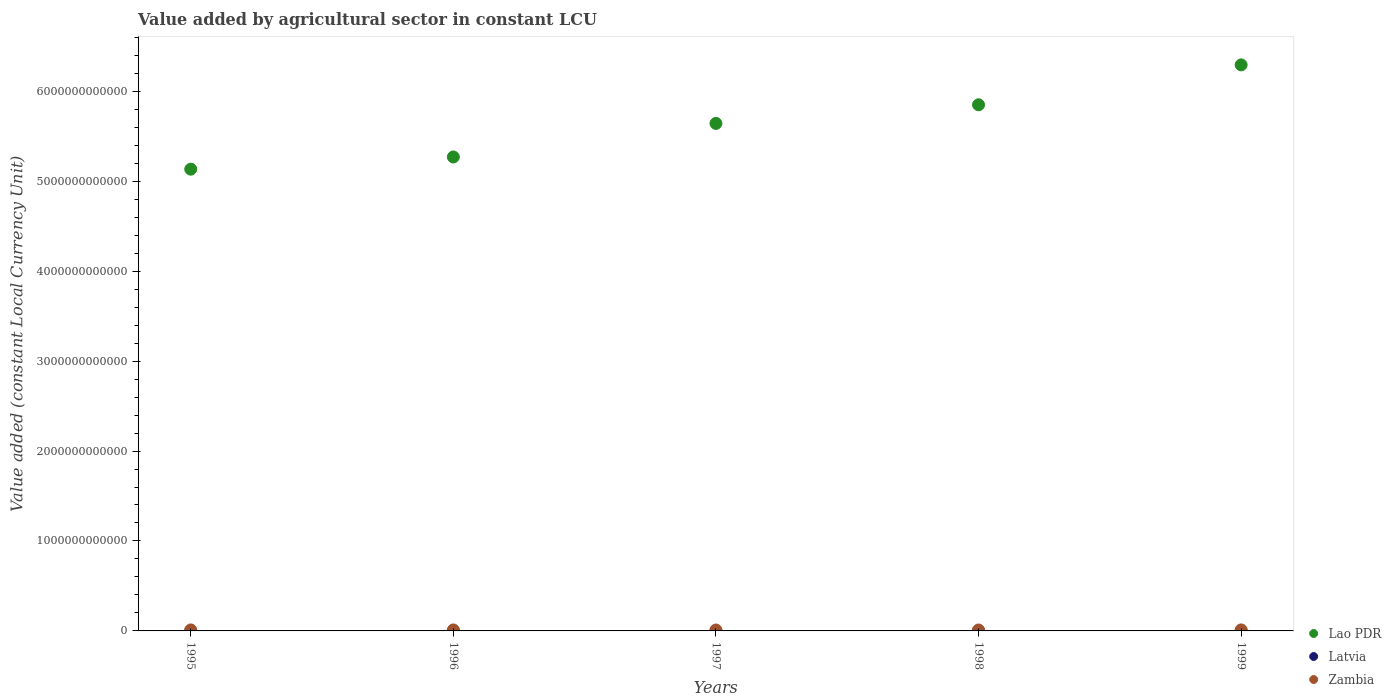How many different coloured dotlines are there?
Offer a very short reply. 3. Is the number of dotlines equal to the number of legend labels?
Provide a short and direct response. Yes. What is the value added by agricultural sector in Lao PDR in 1997?
Your answer should be very brief. 5.64e+12. Across all years, what is the maximum value added by agricultural sector in Zambia?
Offer a very short reply. 1.12e+1. Across all years, what is the minimum value added by agricultural sector in Lao PDR?
Your answer should be very brief. 5.13e+12. What is the total value added by agricultural sector in Zambia in the graph?
Your answer should be compact. 5.40e+1. What is the difference between the value added by agricultural sector in Latvia in 1995 and that in 1999?
Make the answer very short. 5.43e+07. What is the difference between the value added by agricultural sector in Zambia in 1998 and the value added by agricultural sector in Lao PDR in 1996?
Give a very brief answer. -5.26e+12. What is the average value added by agricultural sector in Latvia per year?
Your response must be concise. 4.92e+08. In the year 1999, what is the difference between the value added by agricultural sector in Latvia and value added by agricultural sector in Lao PDR?
Your answer should be very brief. -6.29e+12. In how many years, is the value added by agricultural sector in Latvia greater than 1800000000000 LCU?
Give a very brief answer. 0. What is the ratio of the value added by agricultural sector in Lao PDR in 1998 to that in 1999?
Your answer should be compact. 0.93. Is the value added by agricultural sector in Lao PDR in 1996 less than that in 1998?
Ensure brevity in your answer.  Yes. What is the difference between the highest and the second highest value added by agricultural sector in Latvia?
Your answer should be compact. 6.35e+06. What is the difference between the highest and the lowest value added by agricultural sector in Lao PDR?
Your answer should be compact. 1.16e+12. Is the sum of the value added by agricultural sector in Lao PDR in 1996 and 1997 greater than the maximum value added by agricultural sector in Zambia across all years?
Your answer should be compact. Yes. Is it the case that in every year, the sum of the value added by agricultural sector in Zambia and value added by agricultural sector in Latvia  is greater than the value added by agricultural sector in Lao PDR?
Provide a succinct answer. No. Does the value added by agricultural sector in Latvia monotonically increase over the years?
Provide a short and direct response. No. Is the value added by agricultural sector in Lao PDR strictly less than the value added by agricultural sector in Zambia over the years?
Provide a succinct answer. No. What is the difference between two consecutive major ticks on the Y-axis?
Give a very brief answer. 1.00e+12. Does the graph contain grids?
Provide a short and direct response. No. Where does the legend appear in the graph?
Make the answer very short. Bottom right. What is the title of the graph?
Make the answer very short. Value added by agricultural sector in constant LCU. What is the label or title of the X-axis?
Offer a terse response. Years. What is the label or title of the Y-axis?
Make the answer very short. Value added (constant Local Currency Unit). What is the Value added (constant Local Currency Unit) in Lao PDR in 1995?
Make the answer very short. 5.13e+12. What is the Value added (constant Local Currency Unit) of Latvia in 1995?
Offer a very short reply. 5.19e+08. What is the Value added (constant Local Currency Unit) in Zambia in 1995?
Ensure brevity in your answer.  1.11e+1. What is the Value added (constant Local Currency Unit) of Lao PDR in 1996?
Make the answer very short. 5.27e+12. What is the Value added (constant Local Currency Unit) of Latvia in 1996?
Offer a very short reply. 4.73e+08. What is the Value added (constant Local Currency Unit) of Zambia in 1996?
Keep it short and to the point. 1.10e+1. What is the Value added (constant Local Currency Unit) in Lao PDR in 1997?
Keep it short and to the point. 5.64e+12. What is the Value added (constant Local Currency Unit) of Latvia in 1997?
Provide a short and direct response. 5.13e+08. What is the Value added (constant Local Currency Unit) of Zambia in 1997?
Provide a succinct answer. 1.03e+1. What is the Value added (constant Local Currency Unit) of Lao PDR in 1998?
Your answer should be compact. 5.85e+12. What is the Value added (constant Local Currency Unit) in Latvia in 1998?
Provide a succinct answer. 4.89e+08. What is the Value added (constant Local Currency Unit) in Zambia in 1998?
Keep it short and to the point. 1.03e+1. What is the Value added (constant Local Currency Unit) of Lao PDR in 1999?
Offer a terse response. 6.29e+12. What is the Value added (constant Local Currency Unit) of Latvia in 1999?
Your answer should be very brief. 4.65e+08. What is the Value added (constant Local Currency Unit) of Zambia in 1999?
Give a very brief answer. 1.12e+1. Across all years, what is the maximum Value added (constant Local Currency Unit) of Lao PDR?
Offer a very short reply. 6.29e+12. Across all years, what is the maximum Value added (constant Local Currency Unit) in Latvia?
Your answer should be very brief. 5.19e+08. Across all years, what is the maximum Value added (constant Local Currency Unit) of Zambia?
Your answer should be very brief. 1.12e+1. Across all years, what is the minimum Value added (constant Local Currency Unit) in Lao PDR?
Your answer should be very brief. 5.13e+12. Across all years, what is the minimum Value added (constant Local Currency Unit) of Latvia?
Your answer should be compact. 4.65e+08. Across all years, what is the minimum Value added (constant Local Currency Unit) in Zambia?
Give a very brief answer. 1.03e+1. What is the total Value added (constant Local Currency Unit) of Lao PDR in the graph?
Offer a terse response. 2.82e+13. What is the total Value added (constant Local Currency Unit) of Latvia in the graph?
Offer a terse response. 2.46e+09. What is the total Value added (constant Local Currency Unit) of Zambia in the graph?
Offer a terse response. 5.40e+1. What is the difference between the Value added (constant Local Currency Unit) of Lao PDR in 1995 and that in 1996?
Your response must be concise. -1.35e+11. What is the difference between the Value added (constant Local Currency Unit) of Latvia in 1995 and that in 1996?
Offer a very short reply. 4.67e+07. What is the difference between the Value added (constant Local Currency Unit) of Zambia in 1995 and that in 1996?
Provide a succinct answer. 1.53e+08. What is the difference between the Value added (constant Local Currency Unit) in Lao PDR in 1995 and that in 1997?
Provide a short and direct response. -5.09e+11. What is the difference between the Value added (constant Local Currency Unit) of Latvia in 1995 and that in 1997?
Make the answer very short. 6.35e+06. What is the difference between the Value added (constant Local Currency Unit) of Zambia in 1995 and that in 1997?
Your answer should be very brief. 8.07e+08. What is the difference between the Value added (constant Local Currency Unit) of Lao PDR in 1995 and that in 1998?
Offer a very short reply. -7.16e+11. What is the difference between the Value added (constant Local Currency Unit) of Latvia in 1995 and that in 1998?
Give a very brief answer. 3.02e+07. What is the difference between the Value added (constant Local Currency Unit) in Zambia in 1995 and that in 1998?
Offer a terse response. 7.85e+08. What is the difference between the Value added (constant Local Currency Unit) of Lao PDR in 1995 and that in 1999?
Make the answer very short. -1.16e+12. What is the difference between the Value added (constant Local Currency Unit) of Latvia in 1995 and that in 1999?
Give a very brief answer. 5.43e+07. What is the difference between the Value added (constant Local Currency Unit) in Zambia in 1995 and that in 1999?
Provide a succinct answer. -1.22e+08. What is the difference between the Value added (constant Local Currency Unit) of Lao PDR in 1996 and that in 1997?
Provide a short and direct response. -3.73e+11. What is the difference between the Value added (constant Local Currency Unit) of Latvia in 1996 and that in 1997?
Your answer should be very brief. -4.04e+07. What is the difference between the Value added (constant Local Currency Unit) of Zambia in 1996 and that in 1997?
Provide a short and direct response. 6.54e+08. What is the difference between the Value added (constant Local Currency Unit) of Lao PDR in 1996 and that in 1998?
Ensure brevity in your answer.  -5.80e+11. What is the difference between the Value added (constant Local Currency Unit) of Latvia in 1996 and that in 1998?
Offer a terse response. -1.65e+07. What is the difference between the Value added (constant Local Currency Unit) of Zambia in 1996 and that in 1998?
Provide a succinct answer. 6.32e+08. What is the difference between the Value added (constant Local Currency Unit) of Lao PDR in 1996 and that in 1999?
Ensure brevity in your answer.  -1.02e+12. What is the difference between the Value added (constant Local Currency Unit) of Latvia in 1996 and that in 1999?
Your answer should be very brief. 7.62e+06. What is the difference between the Value added (constant Local Currency Unit) of Zambia in 1996 and that in 1999?
Your answer should be compact. -2.76e+08. What is the difference between the Value added (constant Local Currency Unit) in Lao PDR in 1997 and that in 1998?
Your response must be concise. -2.07e+11. What is the difference between the Value added (constant Local Currency Unit) of Latvia in 1997 and that in 1998?
Provide a short and direct response. 2.39e+07. What is the difference between the Value added (constant Local Currency Unit) of Zambia in 1997 and that in 1998?
Offer a very short reply. -2.18e+07. What is the difference between the Value added (constant Local Currency Unit) of Lao PDR in 1997 and that in 1999?
Provide a succinct answer. -6.51e+11. What is the difference between the Value added (constant Local Currency Unit) of Latvia in 1997 and that in 1999?
Provide a succinct answer. 4.80e+07. What is the difference between the Value added (constant Local Currency Unit) in Zambia in 1997 and that in 1999?
Ensure brevity in your answer.  -9.30e+08. What is the difference between the Value added (constant Local Currency Unit) in Lao PDR in 1998 and that in 1999?
Keep it short and to the point. -4.43e+11. What is the difference between the Value added (constant Local Currency Unit) of Latvia in 1998 and that in 1999?
Offer a very short reply. 2.41e+07. What is the difference between the Value added (constant Local Currency Unit) in Zambia in 1998 and that in 1999?
Your answer should be compact. -9.08e+08. What is the difference between the Value added (constant Local Currency Unit) of Lao PDR in 1995 and the Value added (constant Local Currency Unit) of Latvia in 1996?
Ensure brevity in your answer.  5.13e+12. What is the difference between the Value added (constant Local Currency Unit) of Lao PDR in 1995 and the Value added (constant Local Currency Unit) of Zambia in 1996?
Offer a terse response. 5.12e+12. What is the difference between the Value added (constant Local Currency Unit) of Latvia in 1995 and the Value added (constant Local Currency Unit) of Zambia in 1996?
Your answer should be compact. -1.04e+1. What is the difference between the Value added (constant Local Currency Unit) in Lao PDR in 1995 and the Value added (constant Local Currency Unit) in Latvia in 1997?
Give a very brief answer. 5.13e+12. What is the difference between the Value added (constant Local Currency Unit) in Lao PDR in 1995 and the Value added (constant Local Currency Unit) in Zambia in 1997?
Ensure brevity in your answer.  5.12e+12. What is the difference between the Value added (constant Local Currency Unit) of Latvia in 1995 and the Value added (constant Local Currency Unit) of Zambia in 1997?
Ensure brevity in your answer.  -9.79e+09. What is the difference between the Value added (constant Local Currency Unit) in Lao PDR in 1995 and the Value added (constant Local Currency Unit) in Latvia in 1998?
Provide a succinct answer. 5.13e+12. What is the difference between the Value added (constant Local Currency Unit) of Lao PDR in 1995 and the Value added (constant Local Currency Unit) of Zambia in 1998?
Give a very brief answer. 5.12e+12. What is the difference between the Value added (constant Local Currency Unit) in Latvia in 1995 and the Value added (constant Local Currency Unit) in Zambia in 1998?
Give a very brief answer. -9.82e+09. What is the difference between the Value added (constant Local Currency Unit) in Lao PDR in 1995 and the Value added (constant Local Currency Unit) in Latvia in 1999?
Make the answer very short. 5.13e+12. What is the difference between the Value added (constant Local Currency Unit) of Lao PDR in 1995 and the Value added (constant Local Currency Unit) of Zambia in 1999?
Make the answer very short. 5.12e+12. What is the difference between the Value added (constant Local Currency Unit) in Latvia in 1995 and the Value added (constant Local Currency Unit) in Zambia in 1999?
Keep it short and to the point. -1.07e+1. What is the difference between the Value added (constant Local Currency Unit) of Lao PDR in 1996 and the Value added (constant Local Currency Unit) of Latvia in 1997?
Your answer should be very brief. 5.27e+12. What is the difference between the Value added (constant Local Currency Unit) in Lao PDR in 1996 and the Value added (constant Local Currency Unit) in Zambia in 1997?
Provide a succinct answer. 5.26e+12. What is the difference between the Value added (constant Local Currency Unit) of Latvia in 1996 and the Value added (constant Local Currency Unit) of Zambia in 1997?
Your answer should be very brief. -9.84e+09. What is the difference between the Value added (constant Local Currency Unit) of Lao PDR in 1996 and the Value added (constant Local Currency Unit) of Latvia in 1998?
Your answer should be compact. 5.27e+12. What is the difference between the Value added (constant Local Currency Unit) of Lao PDR in 1996 and the Value added (constant Local Currency Unit) of Zambia in 1998?
Ensure brevity in your answer.  5.26e+12. What is the difference between the Value added (constant Local Currency Unit) of Latvia in 1996 and the Value added (constant Local Currency Unit) of Zambia in 1998?
Give a very brief answer. -9.86e+09. What is the difference between the Value added (constant Local Currency Unit) in Lao PDR in 1996 and the Value added (constant Local Currency Unit) in Latvia in 1999?
Give a very brief answer. 5.27e+12. What is the difference between the Value added (constant Local Currency Unit) in Lao PDR in 1996 and the Value added (constant Local Currency Unit) in Zambia in 1999?
Your answer should be very brief. 5.26e+12. What is the difference between the Value added (constant Local Currency Unit) of Latvia in 1996 and the Value added (constant Local Currency Unit) of Zambia in 1999?
Your response must be concise. -1.08e+1. What is the difference between the Value added (constant Local Currency Unit) of Lao PDR in 1997 and the Value added (constant Local Currency Unit) of Latvia in 1998?
Your answer should be compact. 5.64e+12. What is the difference between the Value added (constant Local Currency Unit) in Lao PDR in 1997 and the Value added (constant Local Currency Unit) in Zambia in 1998?
Provide a succinct answer. 5.63e+12. What is the difference between the Value added (constant Local Currency Unit) of Latvia in 1997 and the Value added (constant Local Currency Unit) of Zambia in 1998?
Provide a succinct answer. -9.82e+09. What is the difference between the Value added (constant Local Currency Unit) in Lao PDR in 1997 and the Value added (constant Local Currency Unit) in Latvia in 1999?
Offer a terse response. 5.64e+12. What is the difference between the Value added (constant Local Currency Unit) in Lao PDR in 1997 and the Value added (constant Local Currency Unit) in Zambia in 1999?
Provide a succinct answer. 5.63e+12. What is the difference between the Value added (constant Local Currency Unit) in Latvia in 1997 and the Value added (constant Local Currency Unit) in Zambia in 1999?
Your response must be concise. -1.07e+1. What is the difference between the Value added (constant Local Currency Unit) in Lao PDR in 1998 and the Value added (constant Local Currency Unit) in Latvia in 1999?
Your response must be concise. 5.85e+12. What is the difference between the Value added (constant Local Currency Unit) of Lao PDR in 1998 and the Value added (constant Local Currency Unit) of Zambia in 1999?
Offer a very short reply. 5.84e+12. What is the difference between the Value added (constant Local Currency Unit) of Latvia in 1998 and the Value added (constant Local Currency Unit) of Zambia in 1999?
Provide a succinct answer. -1.08e+1. What is the average Value added (constant Local Currency Unit) of Lao PDR per year?
Provide a short and direct response. 5.64e+12. What is the average Value added (constant Local Currency Unit) in Latvia per year?
Offer a very short reply. 4.92e+08. What is the average Value added (constant Local Currency Unit) in Zambia per year?
Provide a short and direct response. 1.08e+1. In the year 1995, what is the difference between the Value added (constant Local Currency Unit) of Lao PDR and Value added (constant Local Currency Unit) of Latvia?
Make the answer very short. 5.13e+12. In the year 1995, what is the difference between the Value added (constant Local Currency Unit) of Lao PDR and Value added (constant Local Currency Unit) of Zambia?
Offer a very short reply. 5.12e+12. In the year 1995, what is the difference between the Value added (constant Local Currency Unit) of Latvia and Value added (constant Local Currency Unit) of Zambia?
Make the answer very short. -1.06e+1. In the year 1996, what is the difference between the Value added (constant Local Currency Unit) of Lao PDR and Value added (constant Local Currency Unit) of Latvia?
Provide a succinct answer. 5.27e+12. In the year 1996, what is the difference between the Value added (constant Local Currency Unit) of Lao PDR and Value added (constant Local Currency Unit) of Zambia?
Provide a succinct answer. 5.26e+12. In the year 1996, what is the difference between the Value added (constant Local Currency Unit) in Latvia and Value added (constant Local Currency Unit) in Zambia?
Your response must be concise. -1.05e+1. In the year 1997, what is the difference between the Value added (constant Local Currency Unit) in Lao PDR and Value added (constant Local Currency Unit) in Latvia?
Your response must be concise. 5.64e+12. In the year 1997, what is the difference between the Value added (constant Local Currency Unit) of Lao PDR and Value added (constant Local Currency Unit) of Zambia?
Your answer should be very brief. 5.63e+12. In the year 1997, what is the difference between the Value added (constant Local Currency Unit) of Latvia and Value added (constant Local Currency Unit) of Zambia?
Give a very brief answer. -9.80e+09. In the year 1998, what is the difference between the Value added (constant Local Currency Unit) of Lao PDR and Value added (constant Local Currency Unit) of Latvia?
Provide a succinct answer. 5.85e+12. In the year 1998, what is the difference between the Value added (constant Local Currency Unit) of Lao PDR and Value added (constant Local Currency Unit) of Zambia?
Your response must be concise. 5.84e+12. In the year 1998, what is the difference between the Value added (constant Local Currency Unit) of Latvia and Value added (constant Local Currency Unit) of Zambia?
Your answer should be very brief. -9.85e+09. In the year 1999, what is the difference between the Value added (constant Local Currency Unit) in Lao PDR and Value added (constant Local Currency Unit) in Latvia?
Make the answer very short. 6.29e+12. In the year 1999, what is the difference between the Value added (constant Local Currency Unit) in Lao PDR and Value added (constant Local Currency Unit) in Zambia?
Keep it short and to the point. 6.28e+12. In the year 1999, what is the difference between the Value added (constant Local Currency Unit) of Latvia and Value added (constant Local Currency Unit) of Zambia?
Offer a terse response. -1.08e+1. What is the ratio of the Value added (constant Local Currency Unit) in Lao PDR in 1995 to that in 1996?
Offer a very short reply. 0.97. What is the ratio of the Value added (constant Local Currency Unit) of Latvia in 1995 to that in 1996?
Offer a terse response. 1.1. What is the ratio of the Value added (constant Local Currency Unit) in Lao PDR in 1995 to that in 1997?
Offer a terse response. 0.91. What is the ratio of the Value added (constant Local Currency Unit) in Latvia in 1995 to that in 1997?
Offer a terse response. 1.01. What is the ratio of the Value added (constant Local Currency Unit) in Zambia in 1995 to that in 1997?
Provide a succinct answer. 1.08. What is the ratio of the Value added (constant Local Currency Unit) of Lao PDR in 1995 to that in 1998?
Provide a short and direct response. 0.88. What is the ratio of the Value added (constant Local Currency Unit) of Latvia in 1995 to that in 1998?
Your response must be concise. 1.06. What is the ratio of the Value added (constant Local Currency Unit) of Zambia in 1995 to that in 1998?
Offer a terse response. 1.08. What is the ratio of the Value added (constant Local Currency Unit) of Lao PDR in 1995 to that in 1999?
Your answer should be very brief. 0.82. What is the ratio of the Value added (constant Local Currency Unit) in Latvia in 1995 to that in 1999?
Provide a succinct answer. 1.12. What is the ratio of the Value added (constant Local Currency Unit) in Zambia in 1995 to that in 1999?
Ensure brevity in your answer.  0.99. What is the ratio of the Value added (constant Local Currency Unit) in Lao PDR in 1996 to that in 1997?
Give a very brief answer. 0.93. What is the ratio of the Value added (constant Local Currency Unit) of Latvia in 1996 to that in 1997?
Your answer should be compact. 0.92. What is the ratio of the Value added (constant Local Currency Unit) in Zambia in 1996 to that in 1997?
Keep it short and to the point. 1.06. What is the ratio of the Value added (constant Local Currency Unit) of Lao PDR in 1996 to that in 1998?
Your answer should be compact. 0.9. What is the ratio of the Value added (constant Local Currency Unit) in Latvia in 1996 to that in 1998?
Keep it short and to the point. 0.97. What is the ratio of the Value added (constant Local Currency Unit) of Zambia in 1996 to that in 1998?
Your answer should be compact. 1.06. What is the ratio of the Value added (constant Local Currency Unit) of Lao PDR in 1996 to that in 1999?
Your answer should be compact. 0.84. What is the ratio of the Value added (constant Local Currency Unit) of Latvia in 1996 to that in 1999?
Offer a very short reply. 1.02. What is the ratio of the Value added (constant Local Currency Unit) in Zambia in 1996 to that in 1999?
Ensure brevity in your answer.  0.98. What is the ratio of the Value added (constant Local Currency Unit) of Lao PDR in 1997 to that in 1998?
Provide a short and direct response. 0.96. What is the ratio of the Value added (constant Local Currency Unit) in Latvia in 1997 to that in 1998?
Offer a very short reply. 1.05. What is the ratio of the Value added (constant Local Currency Unit) in Lao PDR in 1997 to that in 1999?
Offer a terse response. 0.9. What is the ratio of the Value added (constant Local Currency Unit) in Latvia in 1997 to that in 1999?
Keep it short and to the point. 1.1. What is the ratio of the Value added (constant Local Currency Unit) in Zambia in 1997 to that in 1999?
Offer a very short reply. 0.92. What is the ratio of the Value added (constant Local Currency Unit) in Lao PDR in 1998 to that in 1999?
Offer a very short reply. 0.93. What is the ratio of the Value added (constant Local Currency Unit) of Latvia in 1998 to that in 1999?
Make the answer very short. 1.05. What is the ratio of the Value added (constant Local Currency Unit) of Zambia in 1998 to that in 1999?
Make the answer very short. 0.92. What is the difference between the highest and the second highest Value added (constant Local Currency Unit) of Lao PDR?
Give a very brief answer. 4.43e+11. What is the difference between the highest and the second highest Value added (constant Local Currency Unit) in Latvia?
Offer a terse response. 6.35e+06. What is the difference between the highest and the second highest Value added (constant Local Currency Unit) of Zambia?
Keep it short and to the point. 1.22e+08. What is the difference between the highest and the lowest Value added (constant Local Currency Unit) of Lao PDR?
Offer a terse response. 1.16e+12. What is the difference between the highest and the lowest Value added (constant Local Currency Unit) in Latvia?
Keep it short and to the point. 5.43e+07. What is the difference between the highest and the lowest Value added (constant Local Currency Unit) of Zambia?
Make the answer very short. 9.30e+08. 